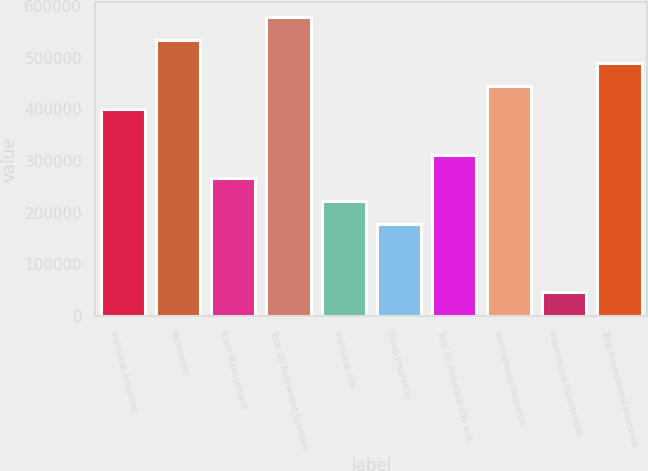Convert chart to OTSL. <chart><loc_0><loc_0><loc_500><loc_500><bar_chart><fcel>Individual Annuities<fcel>Retirement<fcel>Asset Management<fcel>Total US Retirement Solutions<fcel>Individual Life<fcel>Group Insurance<fcel>Total US Individual Life and<fcel>International Insurance<fcel>International Investments<fcel>Total International Insurance<nl><fcel>400606<fcel>533822<fcel>267389<fcel>578228<fcel>222984<fcel>178578<fcel>311794<fcel>445011<fcel>45361.5<fcel>489416<nl></chart> 